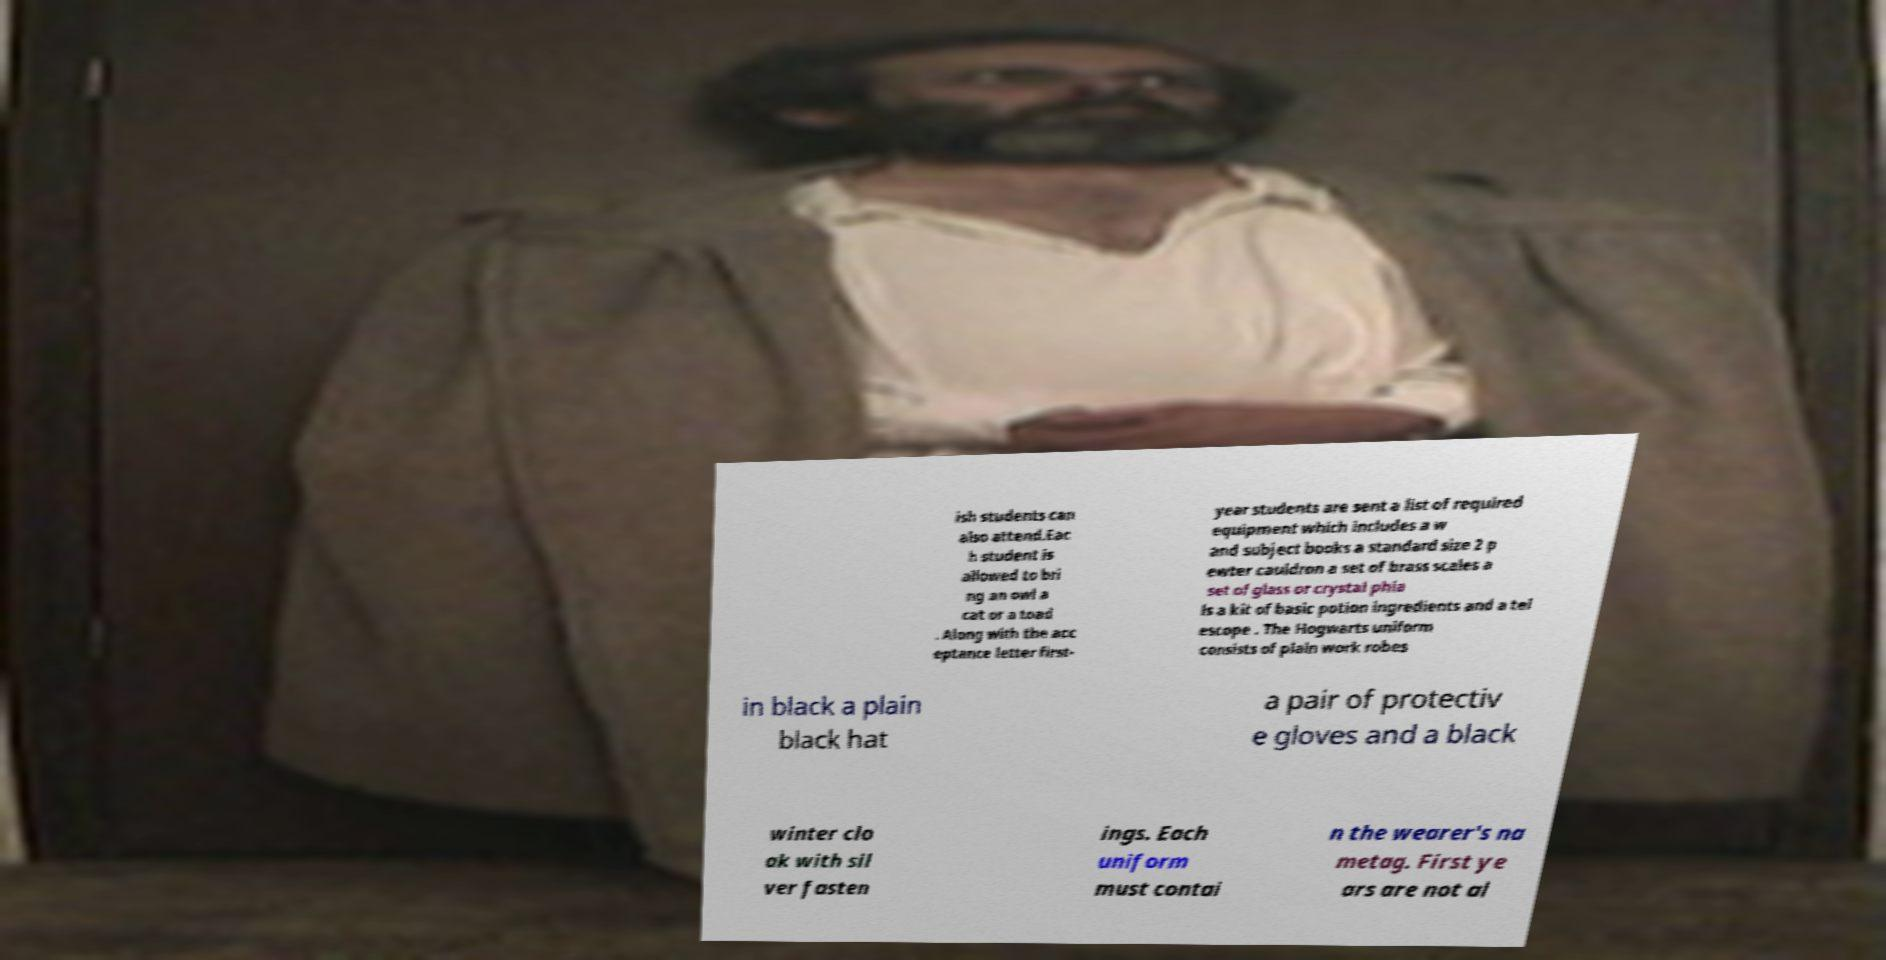Could you extract and type out the text from this image? ish students can also attend.Eac h student is allowed to bri ng an owl a cat or a toad . Along with the acc eptance letter first- year students are sent a list of required equipment which includes a w and subject books a standard size 2 p ewter cauldron a set of brass scales a set of glass or crystal phia ls a kit of basic potion ingredients and a tel escope . The Hogwarts uniform consists of plain work robes in black a plain black hat a pair of protectiv e gloves and a black winter clo ak with sil ver fasten ings. Each uniform must contai n the wearer's na metag. First ye ars are not al 